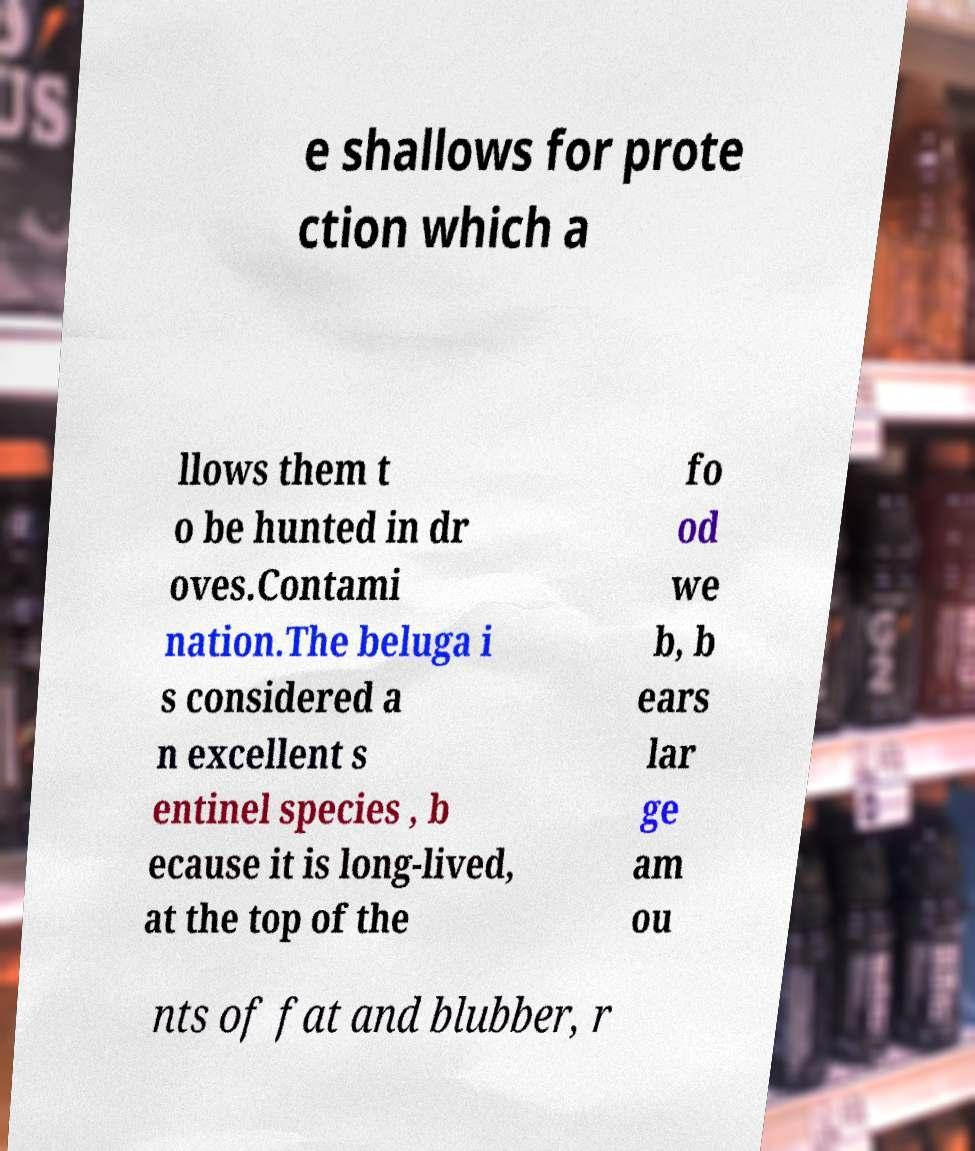Could you assist in decoding the text presented in this image and type it out clearly? e shallows for prote ction which a llows them t o be hunted in dr oves.Contami nation.The beluga i s considered a n excellent s entinel species , b ecause it is long-lived, at the top of the fo od we b, b ears lar ge am ou nts of fat and blubber, r 